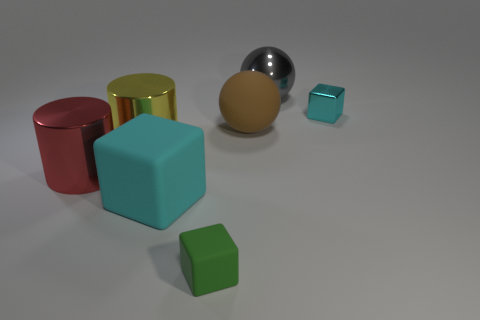What might be the purpose of this collection of objects? The collection of objects could be for a variety of purposes. It may be part of a visual demonstration regarding geometry and color, an artistic arrangement meant to evoke a response based on the contrasts in shape and texture, or perhaps a setup for a photographic composition exercise. 